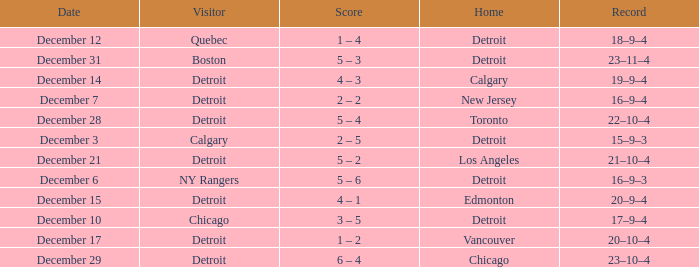Would you mind parsing the complete table? {'header': ['Date', 'Visitor', 'Score', 'Home', 'Record'], 'rows': [['December 12', 'Quebec', '1 – 4', 'Detroit', '18–9–4'], ['December 31', 'Boston', '5 – 3', 'Detroit', '23–11–4'], ['December 14', 'Detroit', '4 – 3', 'Calgary', '19–9–4'], ['December 7', 'Detroit', '2 – 2', 'New Jersey', '16–9–4'], ['December 28', 'Detroit', '5 – 4', 'Toronto', '22–10–4'], ['December 3', 'Calgary', '2 – 5', 'Detroit', '15–9–3'], ['December 21', 'Detroit', '5 – 2', 'Los Angeles', '21–10–4'], ['December 6', 'NY Rangers', '5 – 6', 'Detroit', '16–9–3'], ['December 15', 'Detroit', '4 – 1', 'Edmonton', '20–9–4'], ['December 10', 'Chicago', '3 – 5', 'Detroit', '17–9–4'], ['December 17', 'Detroit', '1 – 2', 'Vancouver', '20–10–4'], ['December 29', 'Detroit', '6 – 4', 'Chicago', '23–10–4']]} What is the score on december 10? 3 – 5. 